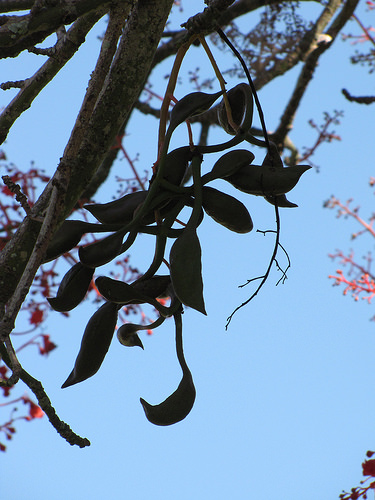<image>
Is there a branch behind the other branch? Yes. From this viewpoint, the branch is positioned behind the other branch, with the other branch partially or fully occluding the branch. 